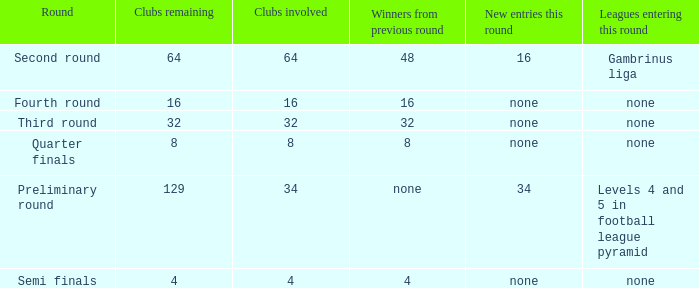Name the new entries this round for third round None. 